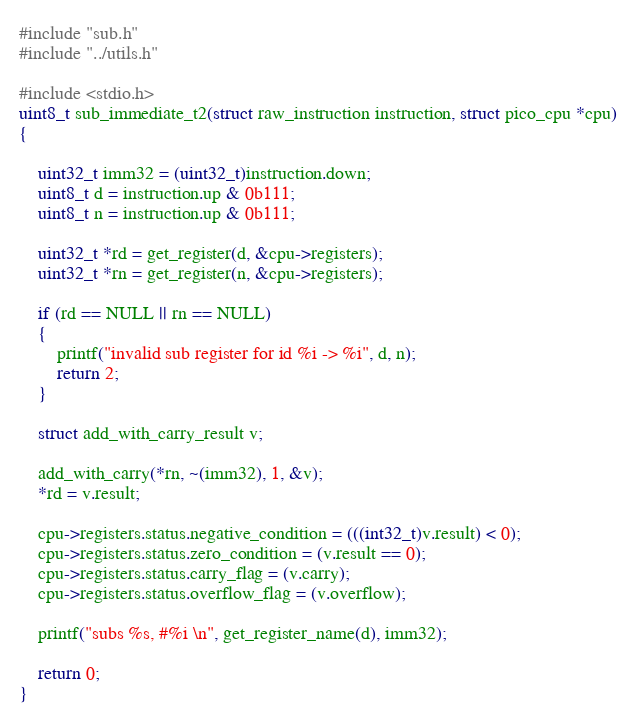Convert code to text. <code><loc_0><loc_0><loc_500><loc_500><_C_>#include "sub.h"
#include "../utils.h"

#include <stdio.h>
uint8_t sub_immediate_t2(struct raw_instruction instruction, struct pico_cpu *cpu)
{

    uint32_t imm32 = (uint32_t)instruction.down;
    uint8_t d = instruction.up & 0b111;
    uint8_t n = instruction.up & 0b111;
    
    uint32_t *rd = get_register(d, &cpu->registers);
    uint32_t *rn = get_register(n, &cpu->registers);

    if (rd == NULL || rn == NULL)
    {
        printf("invalid sub register for id %i -> %i", d, n);
        return 2;
    }

    struct add_with_carry_result v;
    
    add_with_carry(*rn, ~(imm32), 1, &v);
    *rd = v.result;

    cpu->registers.status.negative_condition = (((int32_t)v.result) < 0);
    cpu->registers.status.zero_condition = (v.result == 0);
    cpu->registers.status.carry_flag = (v.carry);
    cpu->registers.status.overflow_flag = (v.overflow);

    printf("subs %s, #%i \n", get_register_name(d), imm32);

    return 0;
}</code> 